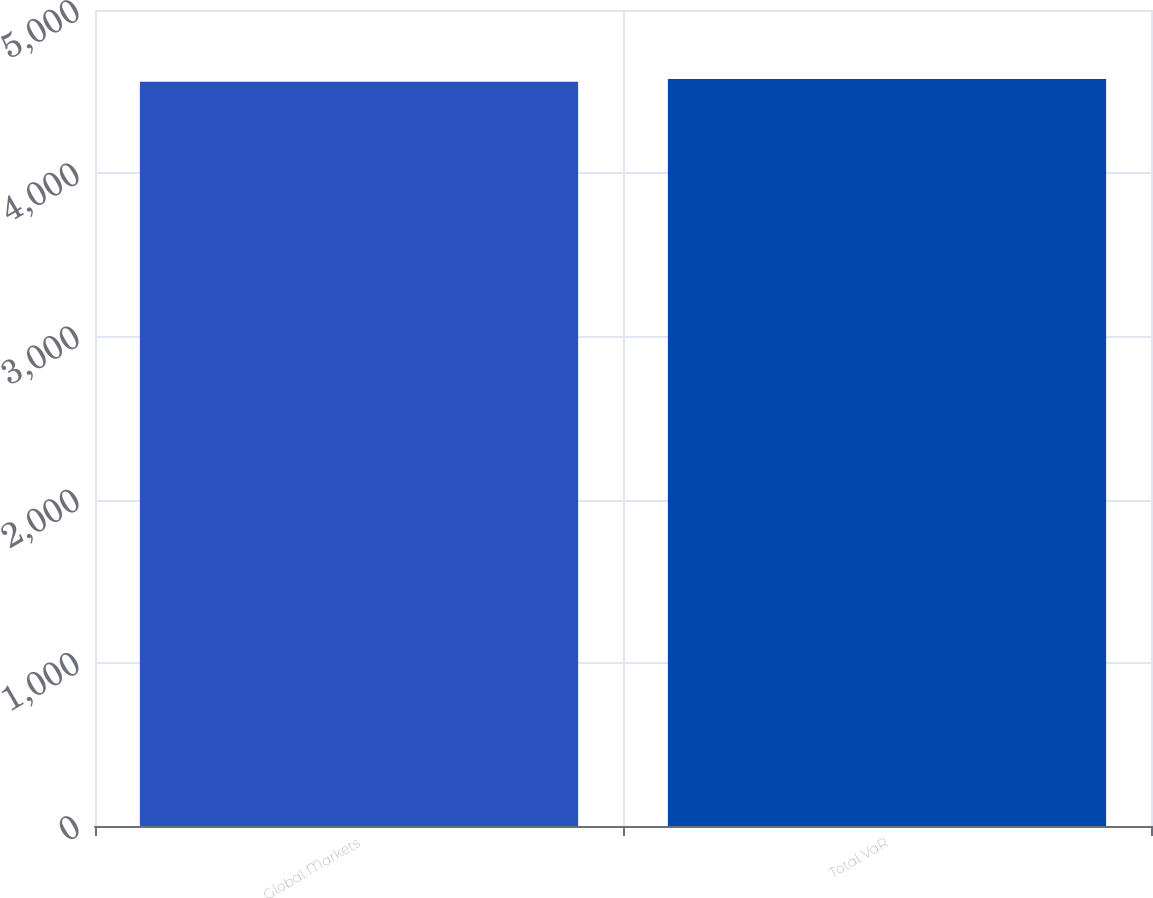<chart> <loc_0><loc_0><loc_500><loc_500><bar_chart><fcel>Global Markets<fcel>Total VaR<nl><fcel>4561<fcel>4577<nl></chart> 